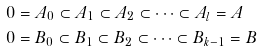<formula> <loc_0><loc_0><loc_500><loc_500>& 0 = A _ { 0 } \subset A _ { 1 } \subset A _ { 2 } \subset \cdots \subset A _ { l } = A \\ & 0 = B _ { 0 } \subset B _ { 1 } \subset B _ { 2 } \subset \cdots \subset B _ { k - 1 } = B</formula> 